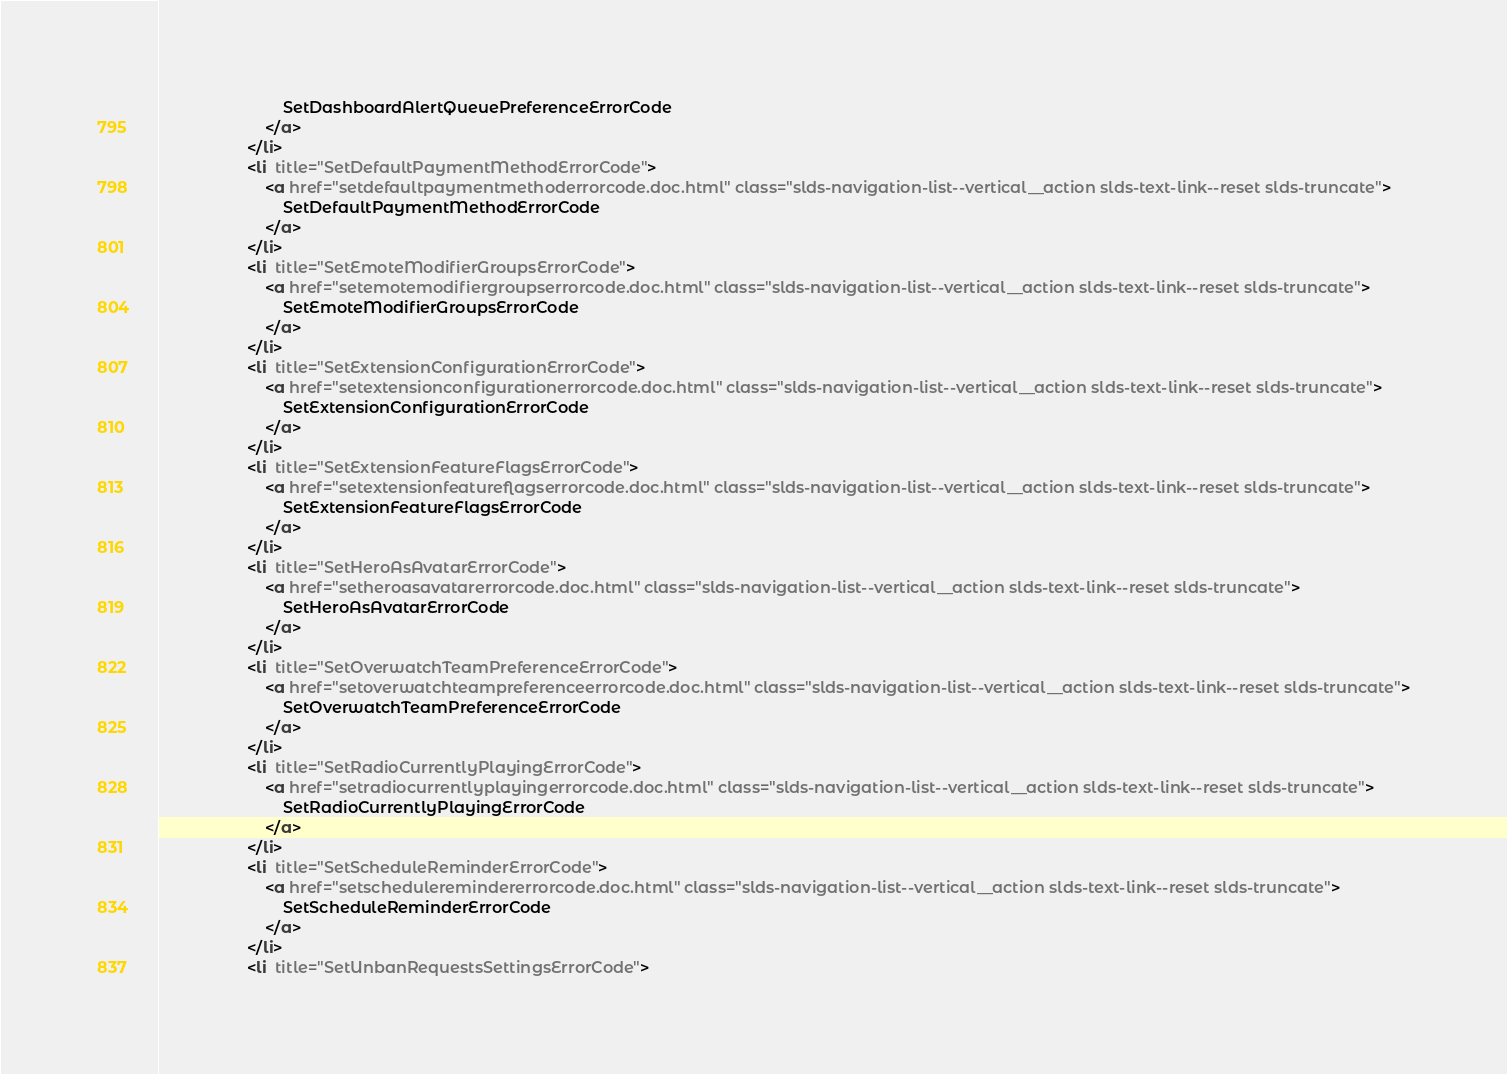<code> <loc_0><loc_0><loc_500><loc_500><_HTML_>                            SetDashboardAlertQueuePreferenceErrorCode
                        </a>
                    </li>
                    <li  title="SetDefaultPaymentMethodErrorCode">
                        <a href="setdefaultpaymentmethoderrorcode.doc.html" class="slds-navigation-list--vertical__action slds-text-link--reset slds-truncate">
                            SetDefaultPaymentMethodErrorCode
                        </a>
                    </li>
                    <li  title="SetEmoteModifierGroupsErrorCode">
                        <a href="setemotemodifiergroupserrorcode.doc.html" class="slds-navigation-list--vertical__action slds-text-link--reset slds-truncate">
                            SetEmoteModifierGroupsErrorCode
                        </a>
                    </li>
                    <li  title="SetExtensionConfigurationErrorCode">
                        <a href="setextensionconfigurationerrorcode.doc.html" class="slds-navigation-list--vertical__action slds-text-link--reset slds-truncate">
                            SetExtensionConfigurationErrorCode
                        </a>
                    </li>
                    <li  title="SetExtensionFeatureFlagsErrorCode">
                        <a href="setextensionfeatureflagserrorcode.doc.html" class="slds-navigation-list--vertical__action slds-text-link--reset slds-truncate">
                            SetExtensionFeatureFlagsErrorCode
                        </a>
                    </li>
                    <li  title="SetHeroAsAvatarErrorCode">
                        <a href="setheroasavatarerrorcode.doc.html" class="slds-navigation-list--vertical__action slds-text-link--reset slds-truncate">
                            SetHeroAsAvatarErrorCode
                        </a>
                    </li>
                    <li  title="SetOverwatchTeamPreferenceErrorCode">
                        <a href="setoverwatchteampreferenceerrorcode.doc.html" class="slds-navigation-list--vertical__action slds-text-link--reset slds-truncate">
                            SetOverwatchTeamPreferenceErrorCode
                        </a>
                    </li>
                    <li  title="SetRadioCurrentlyPlayingErrorCode">
                        <a href="setradiocurrentlyplayingerrorcode.doc.html" class="slds-navigation-list--vertical__action slds-text-link--reset slds-truncate">
                            SetRadioCurrentlyPlayingErrorCode
                        </a>
                    </li>
                    <li  title="SetScheduleReminderErrorCode">
                        <a href="setscheduleremindererrorcode.doc.html" class="slds-navigation-list--vertical__action slds-text-link--reset slds-truncate">
                            SetScheduleReminderErrorCode
                        </a>
                    </li>
                    <li  title="SetUnbanRequestsSettingsErrorCode"></code> 